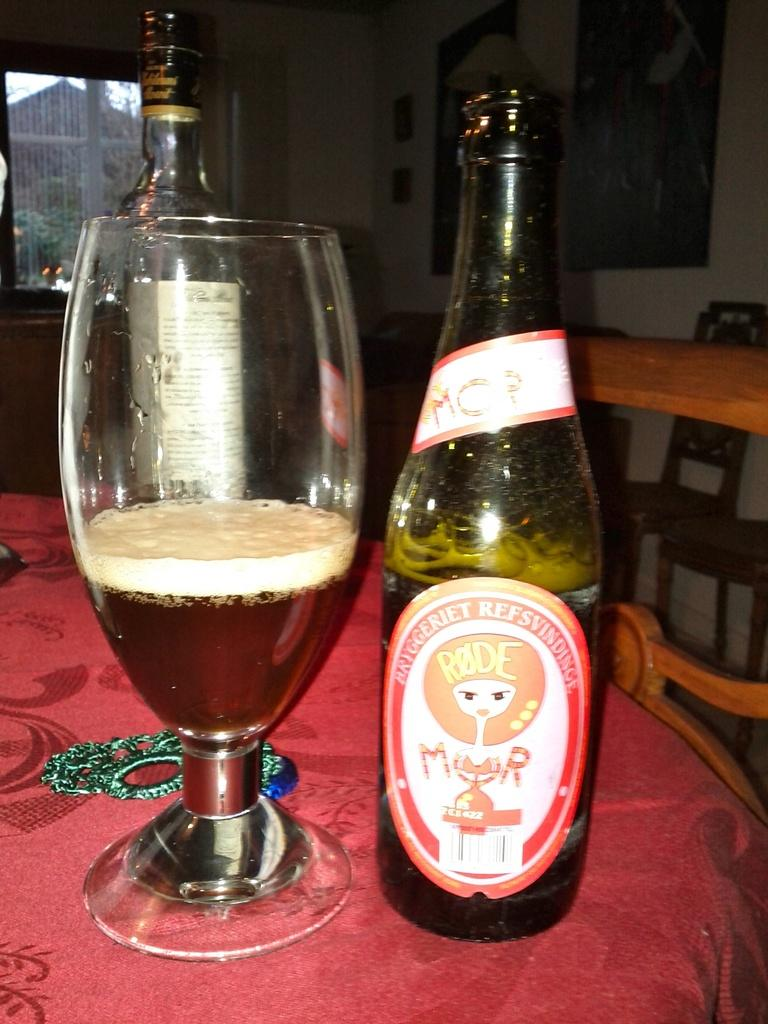Provide a one-sentence caption for the provided image. A bottle of beer with foreign markings spelling out Bryggeriet sits next to a glass cup half filled with it. 